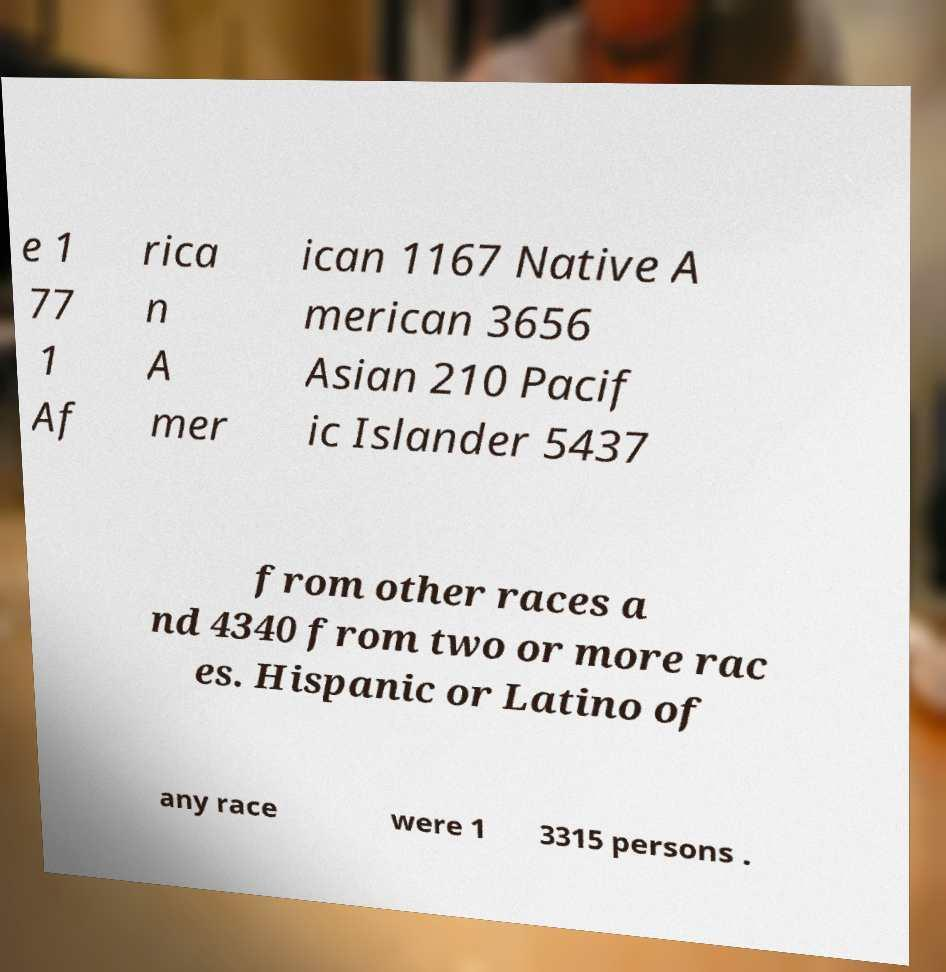Can you read and provide the text displayed in the image?This photo seems to have some interesting text. Can you extract and type it out for me? e 1 77 1 Af rica n A mer ican 1167 Native A merican 3656 Asian 210 Pacif ic Islander 5437 from other races a nd 4340 from two or more rac es. Hispanic or Latino of any race were 1 3315 persons . 